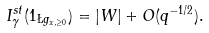Convert formula to latex. <formula><loc_0><loc_0><loc_500><loc_500>I _ { \gamma } ^ { s t } ( 1 _ { \L g _ { x , \geq 0 } } ) = | W | + O ( q ^ { - 1 / 2 } ) .</formula> 